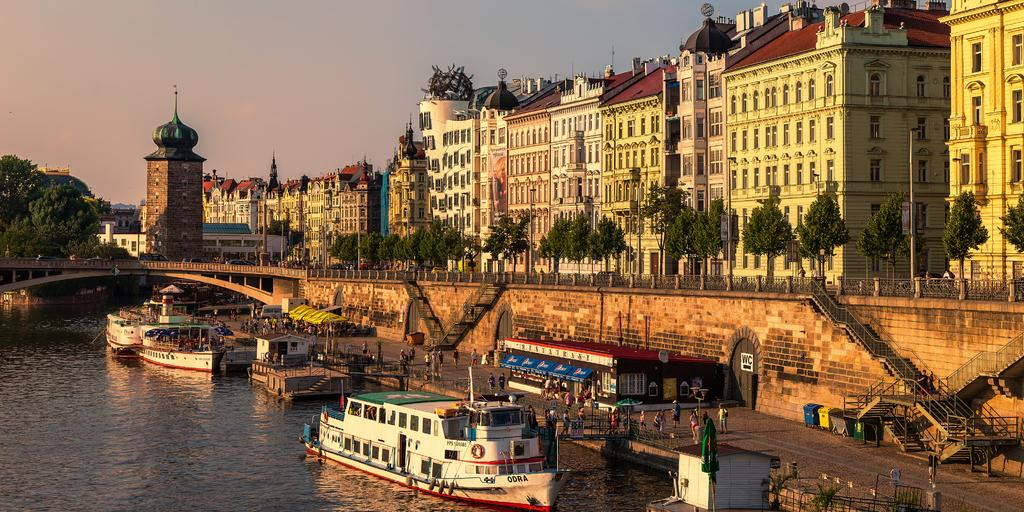What is above the water in the image? There are ships above the water in the image. What structure can be seen with a cloth and a pole? There is a cloth with a pole in the image. Can you identify any living beings in the image? Yes, there are people in the image. What type of man-made structure can be seen in the image? There is a shed in the image. Are there any transportation structures in the image? Yes, there is a bridge in the image. What type of architectural feature is present in the image? There is a wall in the image. What might be used for entering or exiting a building in the image? There are doors in the image. What safety feature can be seen in the image? There are railings in the image. What type of waste disposal units are present in the image? There are bins in the image. What type of vegetation can be seen in the image? There are plants in the image. What type of natural scenery can be seen in the background of the image? There are trees in the background of the image. What type of man-made structures can be seen in the background of the image? There are buildings in the background of the image. What part of the natural environment is visible in the background of the image? There is sky visible in the background of the image. What type of reaction can be seen from the apple in the image? There is no apple present in the image, so no reaction can be observed. What type of teeth can be seen in the image? There are no teeth visible in the image, as the image does not feature any living beings with teeth. 